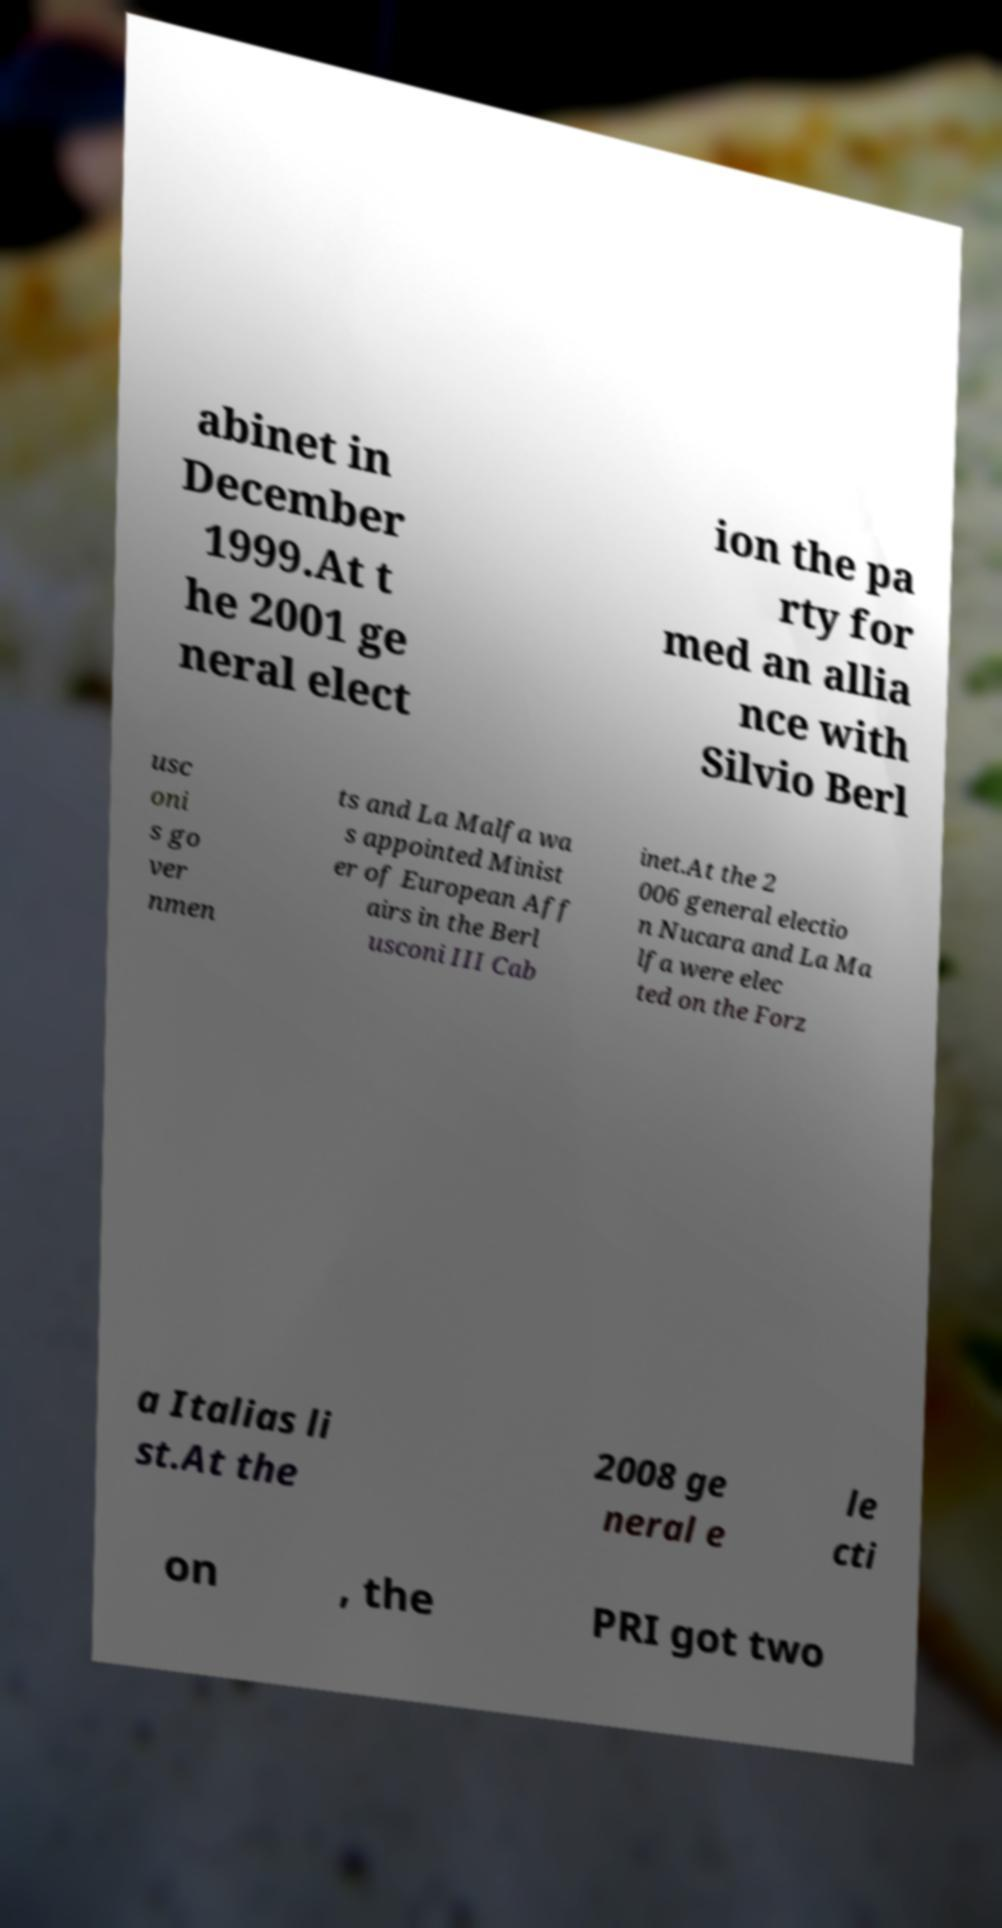Please read and relay the text visible in this image. What does it say? abinet in December 1999.At t he 2001 ge neral elect ion the pa rty for med an allia nce with Silvio Berl usc oni s go ver nmen ts and La Malfa wa s appointed Minist er of European Aff airs in the Berl usconi III Cab inet.At the 2 006 general electio n Nucara and La Ma lfa were elec ted on the Forz a Italias li st.At the 2008 ge neral e le cti on , the PRI got two 